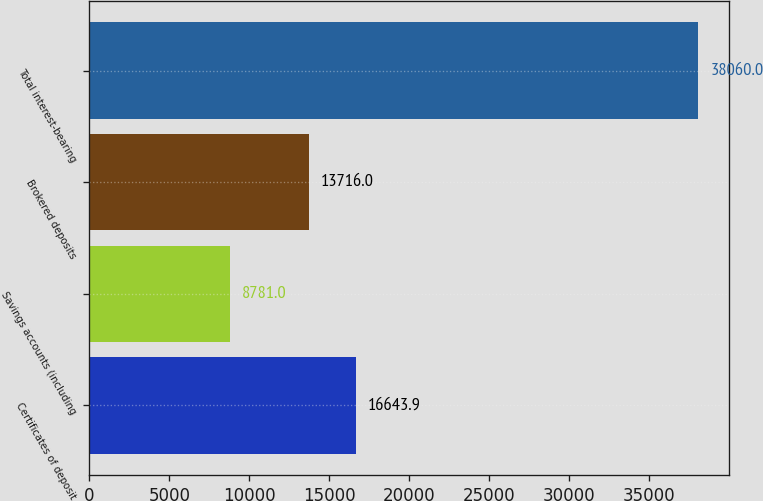Convert chart. <chart><loc_0><loc_0><loc_500><loc_500><bar_chart><fcel>Certificates of deposit<fcel>Savings accounts (including<fcel>Brokered deposits<fcel>Total interest-bearing<nl><fcel>16643.9<fcel>8781<fcel>13716<fcel>38060<nl></chart> 